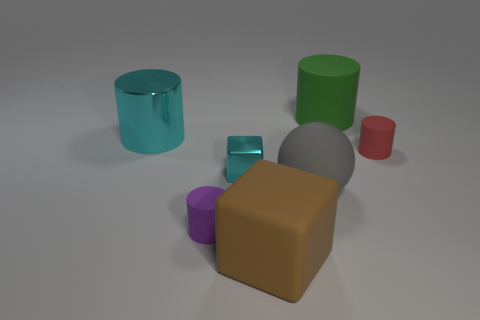Add 3 red cylinders. How many objects exist? 10 Subtract all cubes. How many objects are left? 5 Subtract 0 yellow spheres. How many objects are left? 7 Subtract all big red cubes. Subtract all big things. How many objects are left? 3 Add 6 small matte objects. How many small matte objects are left? 8 Add 5 tiny cyan shiny cubes. How many tiny cyan shiny cubes exist? 6 